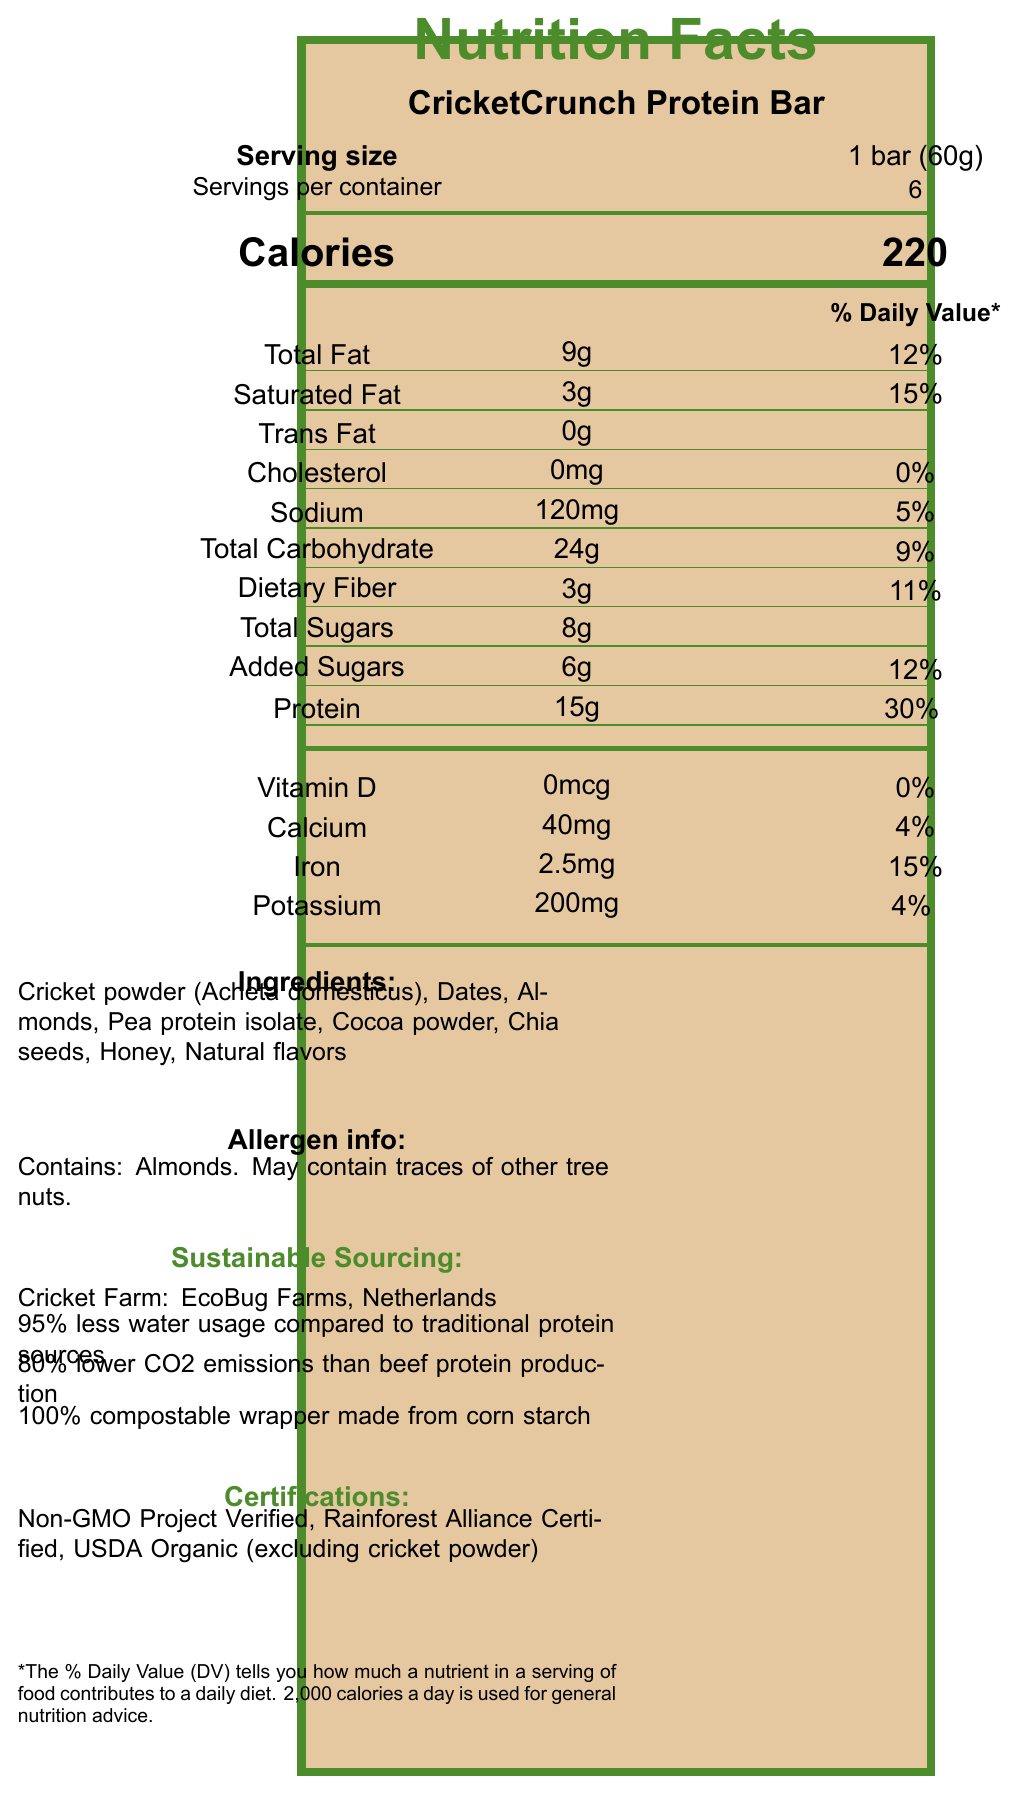what is the serving size? The serving size is clearly listed on the document as "1 bar (60g)".
Answer: 1 bar (60g) how many calories are in one serving? The number of calories per serving is listed as 220 on the document.
Answer: 220 how much protein does the CricketCrunch Protein Bar contain per serving? The protein content is listed in the nutrient information section as 15g per serving.
Answer: 15g list all the essential amino acids present in the CricketCrunch Protein Bar. The amino acids are listed under the amino acid profile section of the document.
Answer: Isoleucine, Leucine, Lysine, Methionine, Phenylalanine, Threonine, Tryptophan, Valine which nutrient has the highest daily value percentage? The protein has the highest daily value percentage at 30%, as listed under the nutrient section.
Answer: Protein (30%) what kind of packaging is used for the CricketCrunch Protein Bar? The packaging is described in the sustainable sourcing section as 100% compostable and made from corn starch.
Answer: 100% compostable wrapper made from corn starch what allergens are contained in the product? The allergen information states that the product contains almonds and may contain traces of other tree nuts.
Answer: Almonds. May contain traces of other tree nuts. where is the cricket farm that supplies the cricket powder? The document mentions that the cricket farm, EcoBug Farms, is located in the Netherlands.
Answer: Netherlands what percentage of the daily value of iron is provided by one serving? The daily value percentage for iron is listed as 15% in the vitamin and mineral information section.
Answer: 15% what certifications does the CricketCrunch Protein Bar have? The certifications are listed under the certifications section: Non-GMO Project Verified, Rainforest Alliance Certified, USDA Organic (excluding cricket powder).
Answer: Non-GMO Project Verified, Rainforest Alliance Certified, USDA Organic (excluding cricket powder) compared to traditional protein sources, how much water does the CricketCrunch Protein Bar production save? The sustainable sourcing section states that the production uses 95% less water compared to traditional protein sources.
Answer: 95% less water what are the main ingredients of the CricketCrunch Protein Bar? The main ingredients are listed under the ingredients section of the document.
Answer: Cricket powder (Acheta domesticus), Dates, Almonds, Pea protein isolate, Cocoa powder, Chia seeds, Honey, Natural flavors how many servings are in one container? A. 4 B. 6 C. 8 D. 12 The document specifies that there are 6 servings per container.
Answer: B. 6 what is the daily value percentage of calcium in the protein bar? A. 4% B. 10% C. 15% D. 20% The daily value percentage for calcium is 4%, as listed under the vitamin and mineral information.
Answer: A. 4% does the CricketCrunch Protein Bar contain Vitamin D? The document states that there is 0mcg of Vitamin D, which is 0% of the daily value.
Answer: No summarize the main points of the CricketCrunch Protein Bar's nutrition facts and sustainable sourcing. The bar is rich in essential amino acids and protein, reflecting its nutritional benefits. Its sustainable sourcing practices include vertical farming and reduced environmental impact, highlighted by the water savings and lower CO2 emissions. The certifications underscore its commitment to quality and sustainability.
Answer: The CricketCrunch Protein Bar contains 220 calories per serving, with notable amounts of protein (15g) and various essential amino acids. It's sustainably sourced, using 95% less water and 80% lower CO2 emissions than traditional protein sources, with a 100% compostable wrapper. The bar is certified Non-GMO, Rainforest Alliance Certified, and USDA Organic (excluding cricket powder). what is the daily value of sodium in one serving? The daily value for sodium is given as 5% in the nutrient information section.
Answer: 5% what is the main idea of the document? The document focuses on presenting the nutritional benefits and the environmentally sustainable aspects of the CricketCrunch Protein Bar.
Answer: The document provides nutritional information and highlights the sustainability aspects of the CricketCrunch Protein Bar, including its amino acid profile, reduced water usage, lower carbon footprint, compostable packaging, and various certifications. what is the total amount of amino acids in one serving of the CricketCrunch Protein Bar? The document provides individual amounts for each amino acid but does not give a total for all amino acids combined.
Answer: Cannot be determined does the bar contain any added sugars? The document lists 6g of added sugars in the nutrient information section.
Answer: Yes list the vitamins and minerals present in the CricketCrunch Protein Bar along with their amounts. The vitamins and minerals with their amounts are listed under the vitamin and mineral information section.
Answer: Vitamin D (0mcg), Calcium (40mg), Iron (2.5mg), Potassium (200mg) 